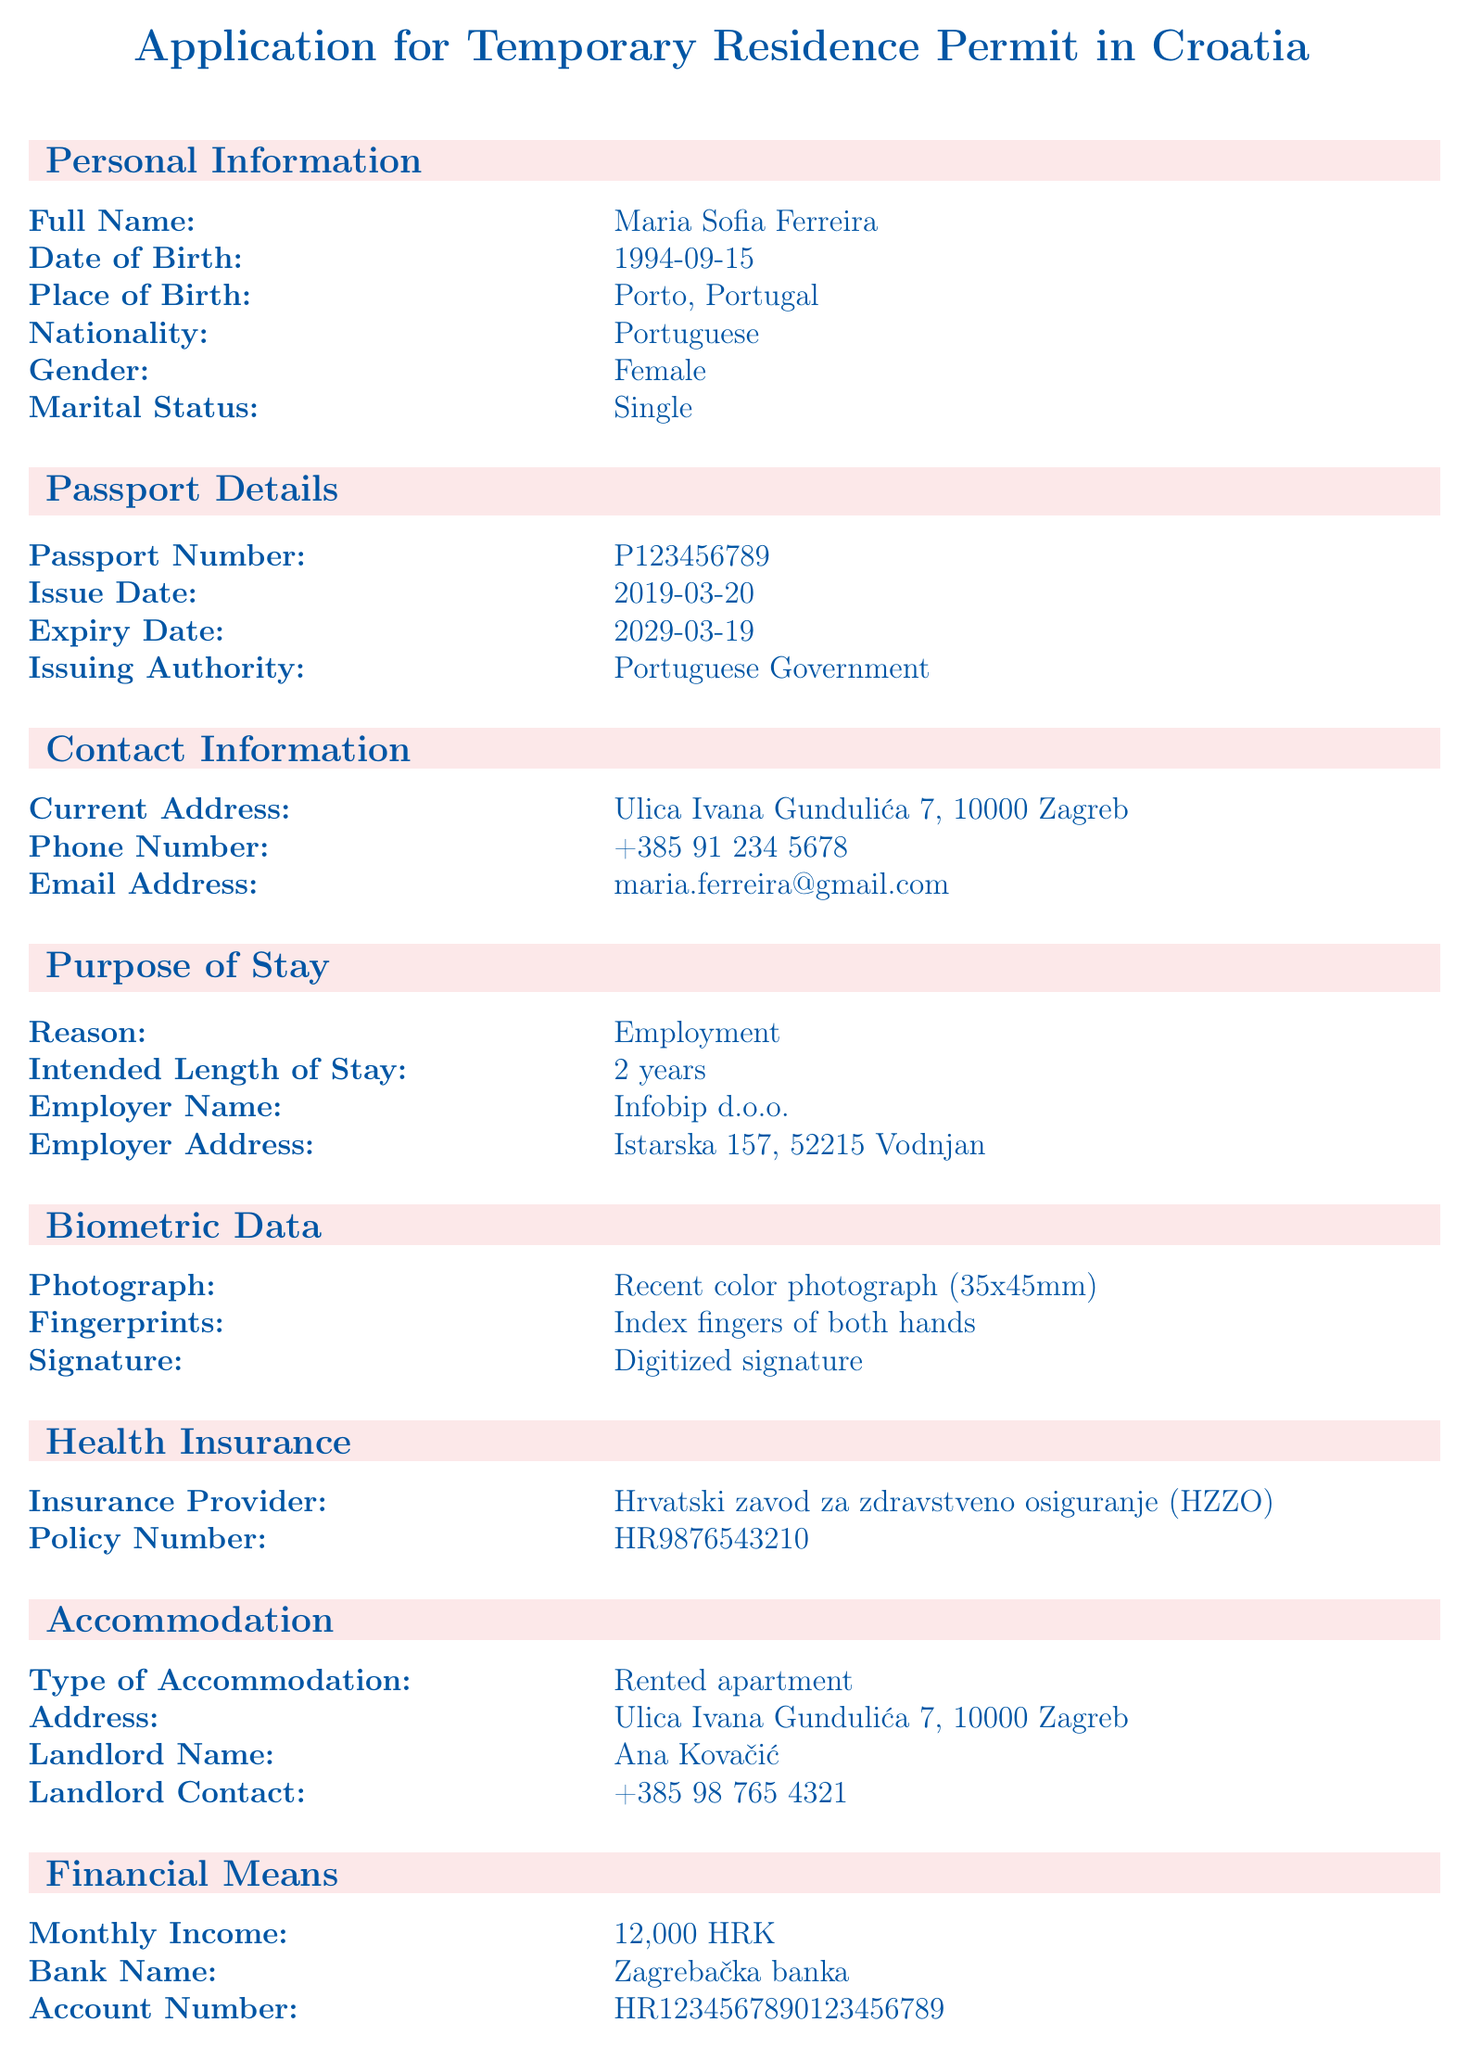What is the applicant's full name? The full name of the applicant is stated in the personal information section of the document.
Answer: Maria Sofia Ferreira What is the applicant's date of birth? The date of birth is provided under the personal information section.
Answer: 1994-09-15 Who is the applicant's employer? The employer's name is mentioned in the purpose of stay section of the document.
Answer: Infobip d.o.o What is the type of accommodation? The type of accommodation is listed in the accommodation section.
Answer: Rented apartment What is the policy number for health insurance? The health insurance policy number can be found in the health insurance section.
Answer: HR9876543210 How long is the intended length of stay? The period for which the stay is intended is indicated in the purpose of stay section.
Answer: 2 years What document is needed to prove qualifications? The additional documents section specifies the necessity of a qualification proof.
Answer: Proof of qualifications Is there a criminal record? The criminal record section indicates whether the applicant has a record or not.
Answer: No Who is the landlord? The landlord's name is provided in the accommodation section of the document.
Answer: Ana Kovačić 